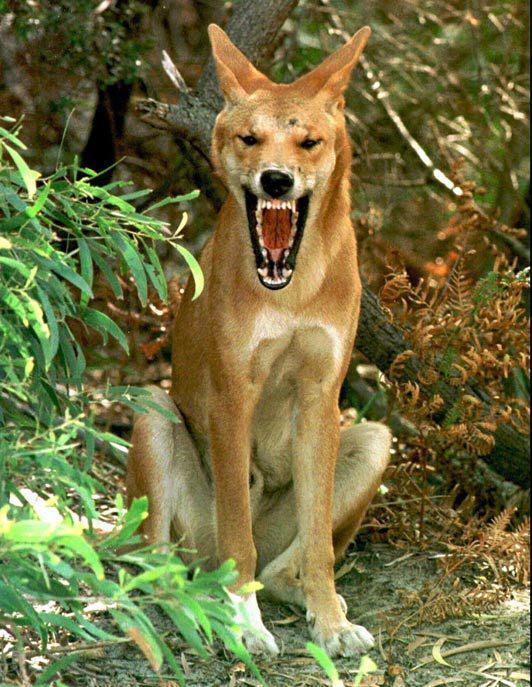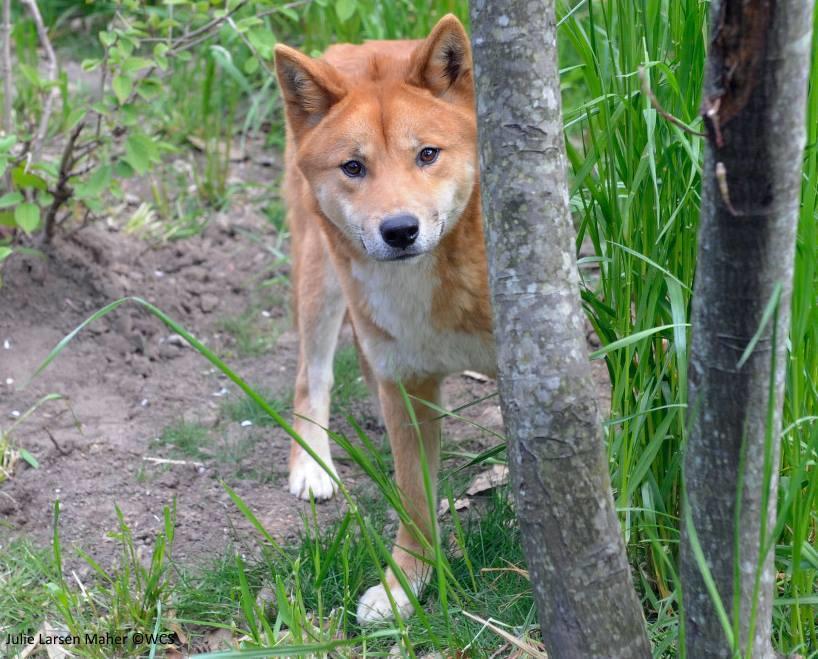The first image is the image on the left, the second image is the image on the right. For the images shown, is this caption "dogs facing the camera straight on" true? Answer yes or no. Yes. The first image is the image on the left, the second image is the image on the right. For the images shown, is this caption "There are multiple canine laying down with there feet in front of them." true? Answer yes or no. No. 